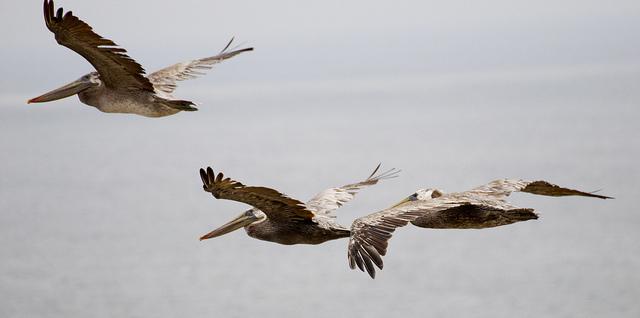Are the birds wings open or closed?
Give a very brief answer. Open. How many birds are flying?
Quick response, please. 3. What are the animals shown?
Quick response, please. Birds. Are the birds flying to the same place?
Quick response, please. Yes. 